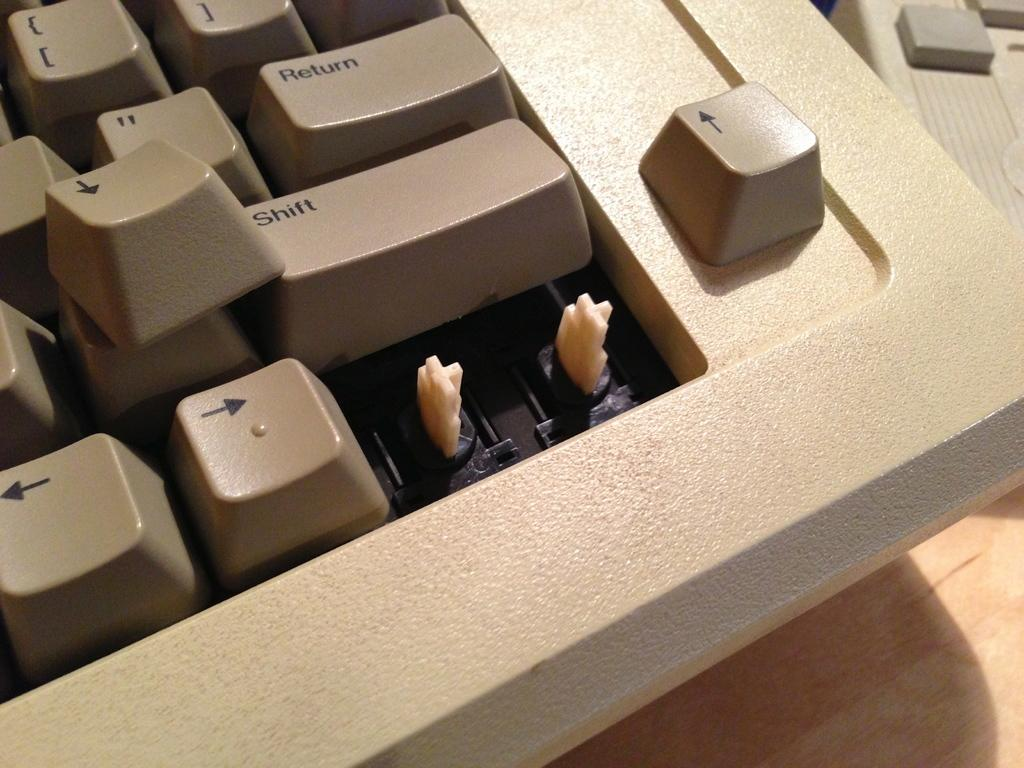<image>
Share a concise interpretation of the image provided. Keyboard keys that has the key RETURN on top of the SHIFT key. 